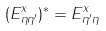Convert formula to latex. <formula><loc_0><loc_0><loc_500><loc_500>( E ^ { x } _ { \eta \eta ^ { \prime } } ) ^ { * } = E ^ { x } _ { \eta ^ { \prime } \eta }</formula> 